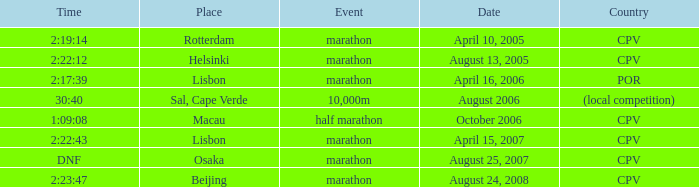What is the Date of the Event with a Time of 2:23:47? August 24, 2008. 